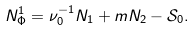Convert formula to latex. <formula><loc_0><loc_0><loc_500><loc_500>N _ { \Phi } ^ { 1 } = \nu _ { 0 } ^ { - 1 } N _ { 1 } + m N _ { 2 } - \mathcal { S } _ { 0 } .</formula> 